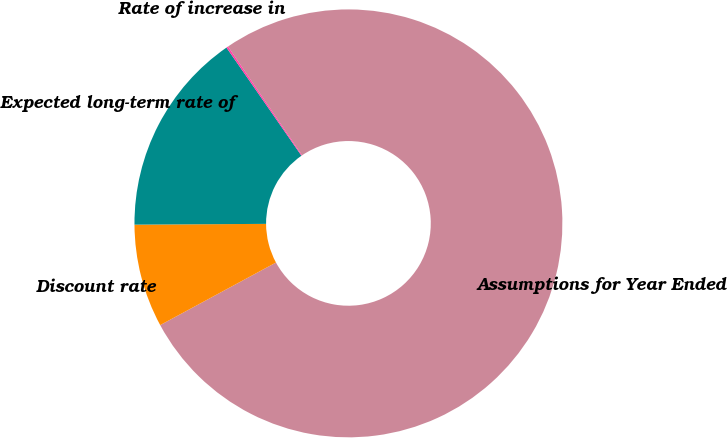<chart> <loc_0><loc_0><loc_500><loc_500><pie_chart><fcel>Assumptions for Year Ended<fcel>Discount rate<fcel>Expected long-term rate of<fcel>Rate of increase in<nl><fcel>76.62%<fcel>7.79%<fcel>15.44%<fcel>0.14%<nl></chart> 